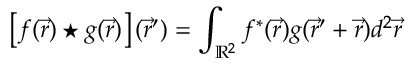Convert formula to latex. <formula><loc_0><loc_0><loc_500><loc_500>\left [ f ( \vec { r } ) ^ { * } g ( \vec { r } ) \right ] ( \vec { r } ^ { \prime } ) = \int _ { \mathbb { R } ^ { 2 } } f ^ { * } ( \vec { r } ) g ( \vec { r } ^ { \prime } + \vec { r } ) d ^ { 2 } \vec { r }</formula> 